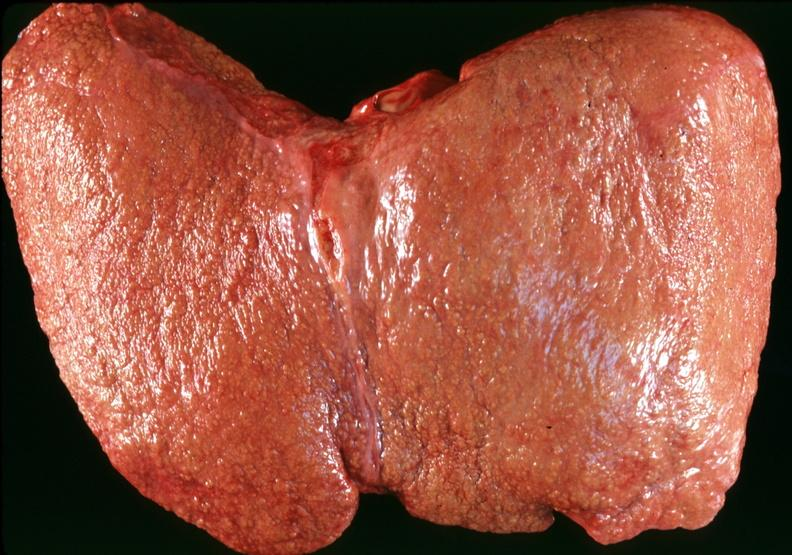s liver present?
Answer the question using a single word or phrase. Yes 